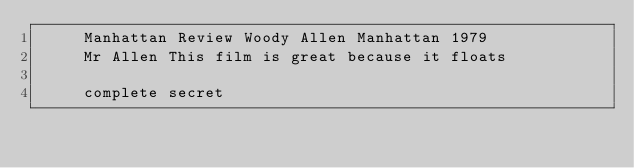Convert code to text. <code><loc_0><loc_0><loc_500><loc_500><_XML_>	 Manhattan Review Woody Allen Manhattan 1979 
	 Mr Allen This film is great because it floats 
	  
	 complete secret 
</code> 